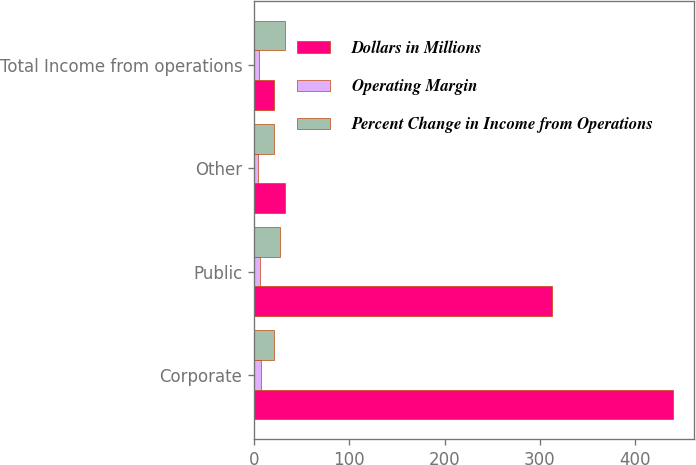Convert chart. <chart><loc_0><loc_0><loc_500><loc_500><stacked_bar_chart><ecel><fcel>Corporate<fcel>Public<fcel>Other<fcel>Total Income from operations<nl><fcel>Dollars in Millions<fcel>439.8<fcel>313.2<fcel>32.9<fcel>21.1<nl><fcel>Operating Margin<fcel>6.8<fcel>6.4<fcel>4.6<fcel>5.6<nl><fcel>Percent Change in Income from Operations<fcel>21.1<fcel>27.1<fcel>20.9<fcel>32.3<nl></chart> 